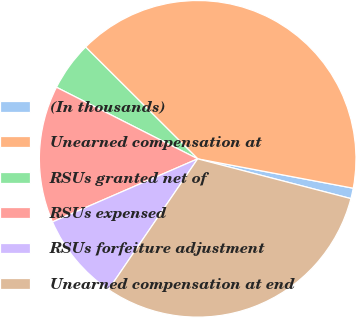Convert chart. <chart><loc_0><loc_0><loc_500><loc_500><pie_chart><fcel>(In thousands)<fcel>Unearned compensation at<fcel>RSUs granted net of<fcel>RSUs expensed<fcel>RSUs forfeiture adjustment<fcel>Unearned compensation at end<nl><fcel>1.07%<fcel>40.49%<fcel>5.01%<fcel>13.99%<fcel>8.95%<fcel>30.48%<nl></chart> 